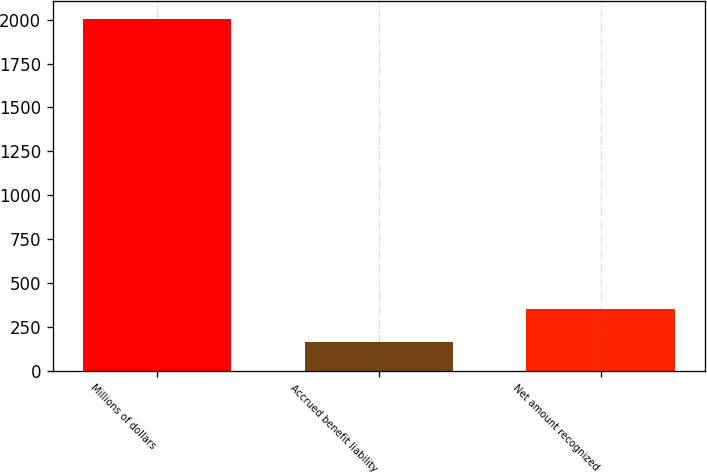Convert chart. <chart><loc_0><loc_0><loc_500><loc_500><bar_chart><fcel>Millions of dollars<fcel>Accrued benefit liability<fcel>Net amount recognized<nl><fcel>2004<fcel>166<fcel>349.8<nl></chart> 